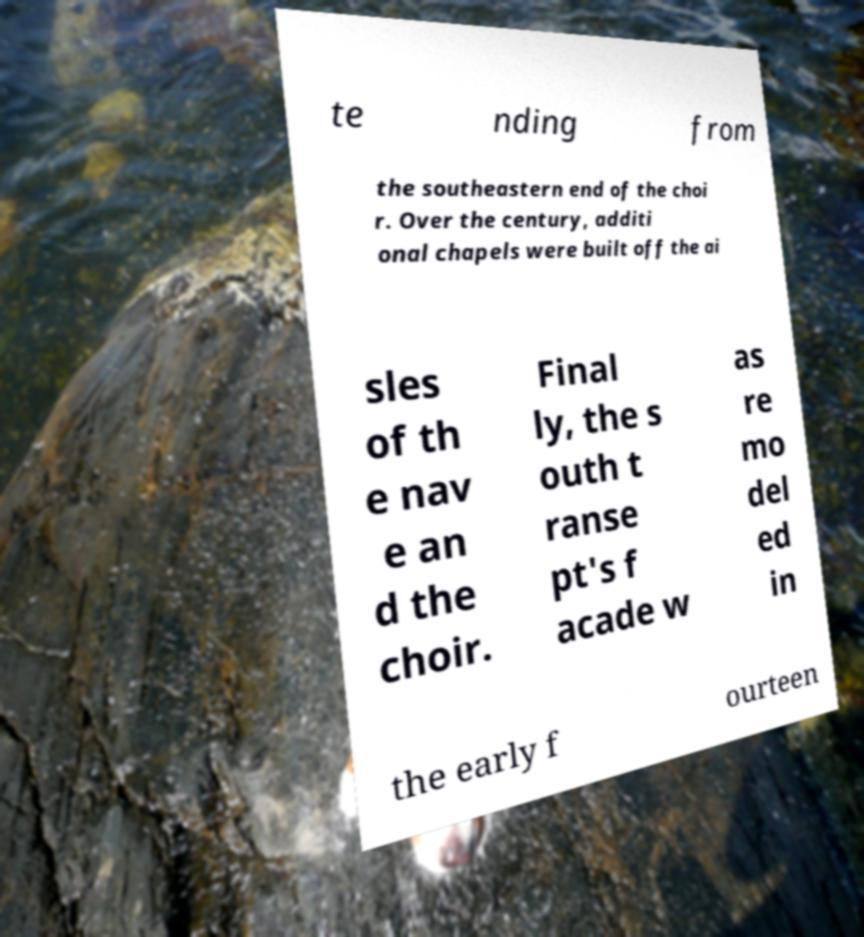What messages or text are displayed in this image? I need them in a readable, typed format. te nding from the southeastern end of the choi r. Over the century, additi onal chapels were built off the ai sles of th e nav e an d the choir. Final ly, the s outh t ranse pt's f acade w as re mo del ed in the early f ourteen 